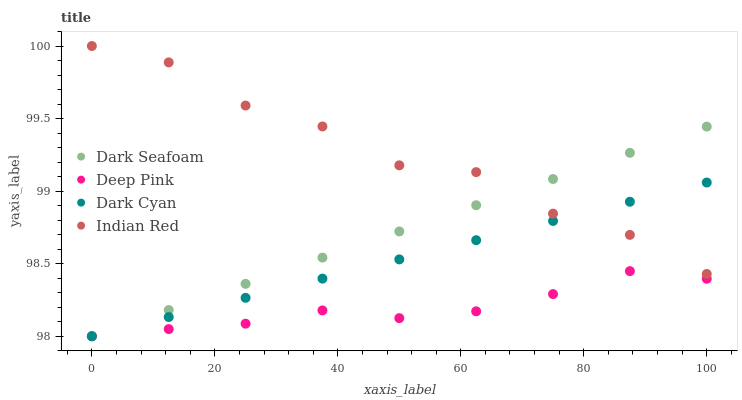Does Deep Pink have the minimum area under the curve?
Answer yes or no. Yes. Does Indian Red have the maximum area under the curve?
Answer yes or no. Yes. Does Dark Seafoam have the minimum area under the curve?
Answer yes or no. No. Does Dark Seafoam have the maximum area under the curve?
Answer yes or no. No. Is Dark Cyan the smoothest?
Answer yes or no. Yes. Is Indian Red the roughest?
Answer yes or no. Yes. Is Dark Seafoam the smoothest?
Answer yes or no. No. Is Dark Seafoam the roughest?
Answer yes or no. No. Does Dark Cyan have the lowest value?
Answer yes or no. Yes. Does Indian Red have the lowest value?
Answer yes or no. No. Does Indian Red have the highest value?
Answer yes or no. Yes. Does Dark Seafoam have the highest value?
Answer yes or no. No. Is Deep Pink less than Indian Red?
Answer yes or no. Yes. Is Indian Red greater than Deep Pink?
Answer yes or no. Yes. Does Indian Red intersect Dark Cyan?
Answer yes or no. Yes. Is Indian Red less than Dark Cyan?
Answer yes or no. No. Is Indian Red greater than Dark Cyan?
Answer yes or no. No. Does Deep Pink intersect Indian Red?
Answer yes or no. No. 